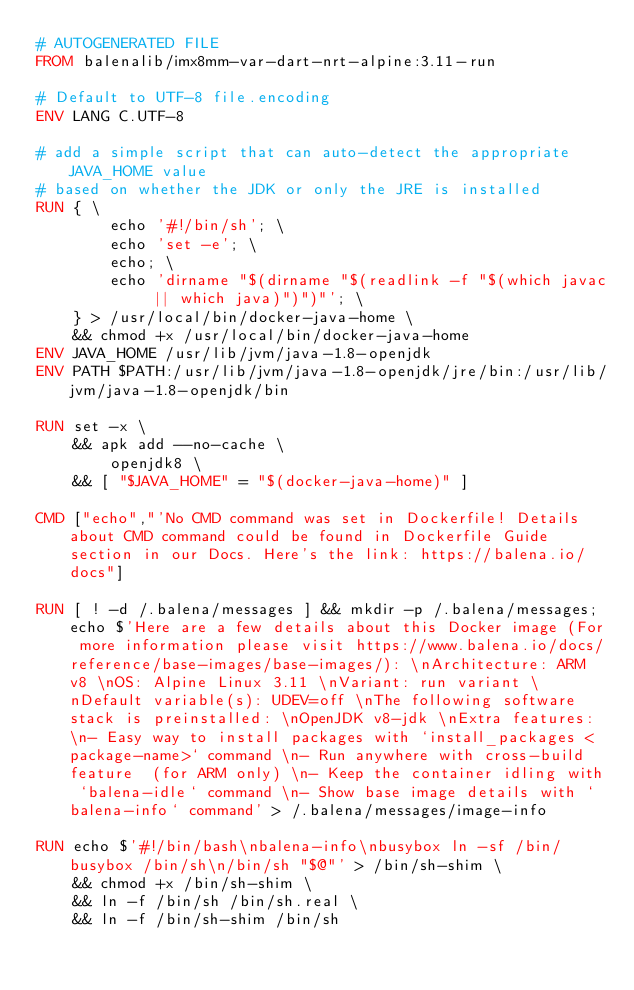<code> <loc_0><loc_0><loc_500><loc_500><_Dockerfile_># AUTOGENERATED FILE
FROM balenalib/imx8mm-var-dart-nrt-alpine:3.11-run

# Default to UTF-8 file.encoding
ENV LANG C.UTF-8

# add a simple script that can auto-detect the appropriate JAVA_HOME value
# based on whether the JDK or only the JRE is installed
RUN { \
		echo '#!/bin/sh'; \
		echo 'set -e'; \
		echo; \
		echo 'dirname "$(dirname "$(readlink -f "$(which javac || which java)")")"'; \
	} > /usr/local/bin/docker-java-home \
	&& chmod +x /usr/local/bin/docker-java-home
ENV JAVA_HOME /usr/lib/jvm/java-1.8-openjdk
ENV PATH $PATH:/usr/lib/jvm/java-1.8-openjdk/jre/bin:/usr/lib/jvm/java-1.8-openjdk/bin

RUN set -x \
	&& apk add --no-cache \
		openjdk8 \
	&& [ "$JAVA_HOME" = "$(docker-java-home)" ]

CMD ["echo","'No CMD command was set in Dockerfile! Details about CMD command could be found in Dockerfile Guide section in our Docs. Here's the link: https://balena.io/docs"]

RUN [ ! -d /.balena/messages ] && mkdir -p /.balena/messages; echo $'Here are a few details about this Docker image (For more information please visit https://www.balena.io/docs/reference/base-images/base-images/): \nArchitecture: ARM v8 \nOS: Alpine Linux 3.11 \nVariant: run variant \nDefault variable(s): UDEV=off \nThe following software stack is preinstalled: \nOpenJDK v8-jdk \nExtra features: \n- Easy way to install packages with `install_packages <package-name>` command \n- Run anywhere with cross-build feature  (for ARM only) \n- Keep the container idling with `balena-idle` command \n- Show base image details with `balena-info` command' > /.balena/messages/image-info

RUN echo $'#!/bin/bash\nbalena-info\nbusybox ln -sf /bin/busybox /bin/sh\n/bin/sh "$@"' > /bin/sh-shim \
	&& chmod +x /bin/sh-shim \
	&& ln -f /bin/sh /bin/sh.real \
	&& ln -f /bin/sh-shim /bin/sh</code> 